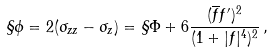Convert formula to latex. <formula><loc_0><loc_0><loc_500><loc_500>\S \phi = 2 ( \sigma _ { z z } - \sigma _ { z } ) = \S \Phi + 6 \frac { ( \overline { f } f ^ { \prime } ) ^ { 2 } } { ( 1 + | f | ^ { 4 } ) ^ { 2 } } \, ,</formula> 